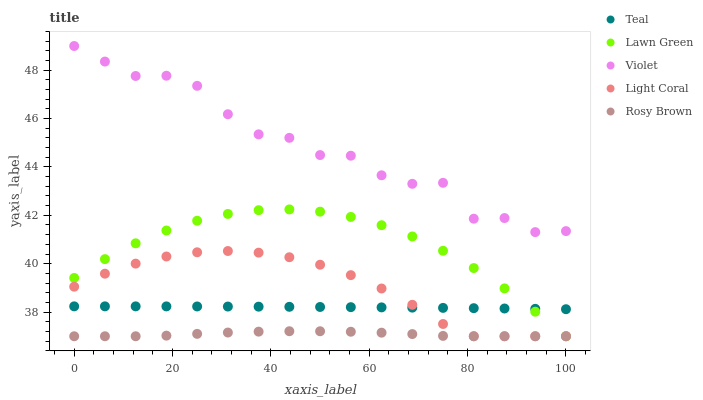Does Rosy Brown have the minimum area under the curve?
Answer yes or no. Yes. Does Violet have the maximum area under the curve?
Answer yes or no. Yes. Does Lawn Green have the minimum area under the curve?
Answer yes or no. No. Does Lawn Green have the maximum area under the curve?
Answer yes or no. No. Is Teal the smoothest?
Answer yes or no. Yes. Is Violet the roughest?
Answer yes or no. Yes. Is Lawn Green the smoothest?
Answer yes or no. No. Is Lawn Green the roughest?
Answer yes or no. No. Does Light Coral have the lowest value?
Answer yes or no. Yes. Does Teal have the lowest value?
Answer yes or no. No. Does Violet have the highest value?
Answer yes or no. Yes. Does Lawn Green have the highest value?
Answer yes or no. No. Is Teal less than Violet?
Answer yes or no. Yes. Is Violet greater than Teal?
Answer yes or no. Yes. Does Light Coral intersect Rosy Brown?
Answer yes or no. Yes. Is Light Coral less than Rosy Brown?
Answer yes or no. No. Is Light Coral greater than Rosy Brown?
Answer yes or no. No. Does Teal intersect Violet?
Answer yes or no. No. 